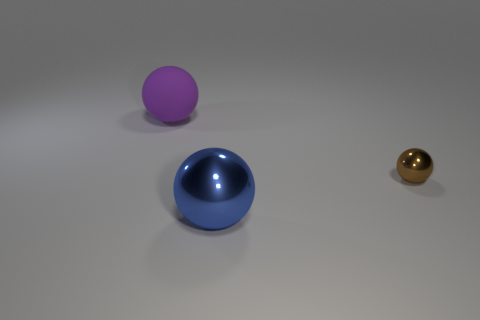What color is the big thing right of the big object that is behind the brown ball? The large object to the right of the central object, which is behind the brown ball, is bright blue with a reflective surface that gives it a shiny appearance. 